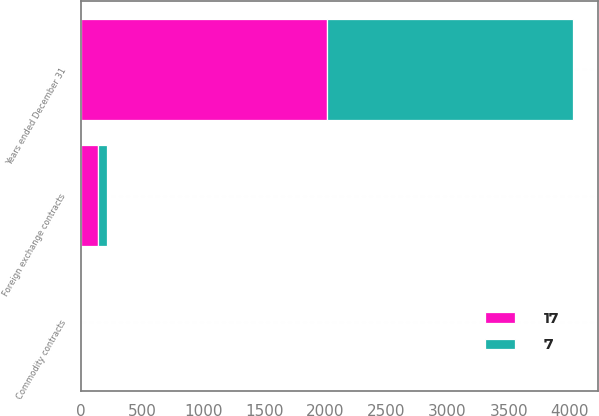Convert chart to OTSL. <chart><loc_0><loc_0><loc_500><loc_500><stacked_bar_chart><ecel><fcel>Years ended December 31<fcel>Foreign exchange contracts<fcel>Commodity contracts<nl><fcel>17<fcel>2014<fcel>135<fcel>2<nl><fcel>7<fcel>2013<fcel>76<fcel>1<nl></chart> 